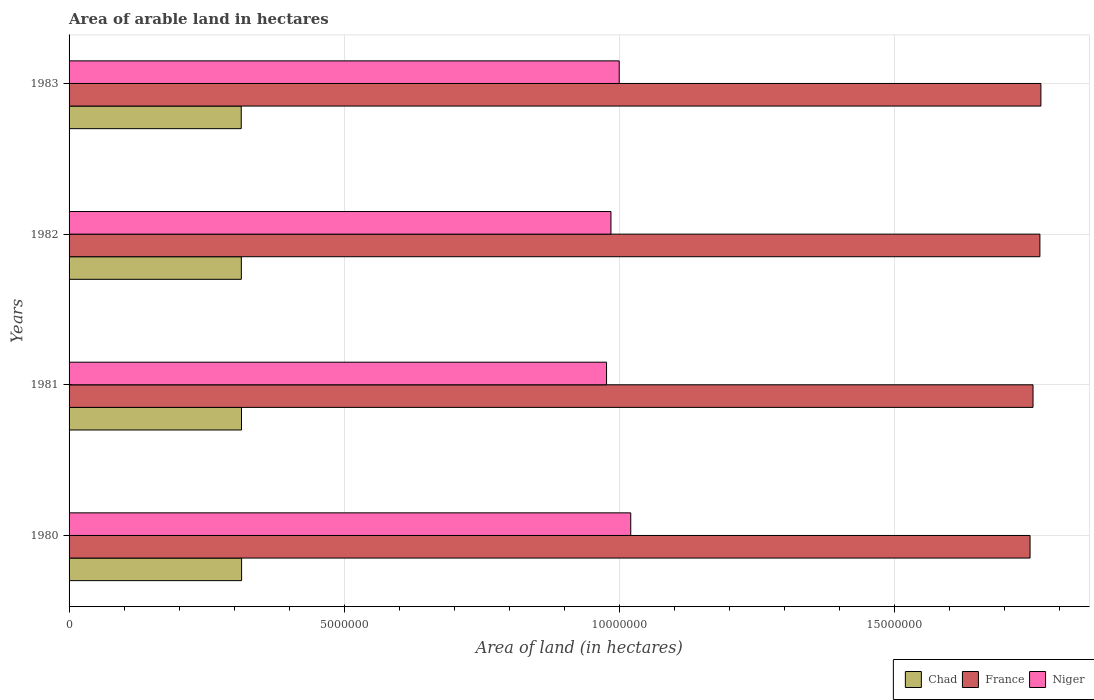How many different coloured bars are there?
Keep it short and to the point. 3. How many bars are there on the 3rd tick from the top?
Offer a very short reply. 3. What is the label of the 2nd group of bars from the top?
Give a very brief answer. 1982. In how many cases, is the number of bars for a given year not equal to the number of legend labels?
Keep it short and to the point. 0. What is the total arable land in Niger in 1981?
Keep it short and to the point. 9.77e+06. Across all years, what is the maximum total arable land in France?
Your answer should be compact. 1.77e+07. Across all years, what is the minimum total arable land in Chad?
Your answer should be very brief. 3.13e+06. In which year was the total arable land in Niger maximum?
Your answer should be compact. 1980. What is the total total arable land in France in the graph?
Make the answer very short. 7.03e+07. What is the difference between the total arable land in Chad in 1980 and that in 1983?
Your response must be concise. 7000. What is the difference between the total arable land in Niger in 1980 and the total arable land in France in 1982?
Ensure brevity in your answer.  -7.44e+06. What is the average total arable land in Chad per year?
Give a very brief answer. 3.13e+06. In the year 1980, what is the difference between the total arable land in France and total arable land in Chad?
Provide a short and direct response. 1.43e+07. What is the ratio of the total arable land in France in 1980 to that in 1983?
Provide a short and direct response. 0.99. Is the total arable land in Chad in 1980 less than that in 1983?
Make the answer very short. No. What is the difference between the highest and the lowest total arable land in Niger?
Offer a terse response. 4.40e+05. In how many years, is the total arable land in Niger greater than the average total arable land in Niger taken over all years?
Your response must be concise. 2. Is the sum of the total arable land in France in 1981 and 1982 greater than the maximum total arable land in Niger across all years?
Your answer should be very brief. Yes. What does the 3rd bar from the top in 1982 represents?
Your response must be concise. Chad. Is it the case that in every year, the sum of the total arable land in Chad and total arable land in Niger is greater than the total arable land in France?
Ensure brevity in your answer.  No. How many bars are there?
Your answer should be very brief. 12. Are the values on the major ticks of X-axis written in scientific E-notation?
Provide a short and direct response. No. Where does the legend appear in the graph?
Give a very brief answer. Bottom right. How many legend labels are there?
Make the answer very short. 3. How are the legend labels stacked?
Your response must be concise. Horizontal. What is the title of the graph?
Keep it short and to the point. Area of arable land in hectares. Does "Lao PDR" appear as one of the legend labels in the graph?
Make the answer very short. No. What is the label or title of the X-axis?
Provide a short and direct response. Area of land (in hectares). What is the Area of land (in hectares) of Chad in 1980?
Provide a short and direct response. 3.14e+06. What is the Area of land (in hectares) of France in 1980?
Make the answer very short. 1.75e+07. What is the Area of land (in hectares) of Niger in 1980?
Offer a very short reply. 1.02e+07. What is the Area of land (in hectares) in Chad in 1981?
Your answer should be compact. 3.14e+06. What is the Area of land (in hectares) of France in 1981?
Ensure brevity in your answer.  1.75e+07. What is the Area of land (in hectares) of Niger in 1981?
Your response must be concise. 9.77e+06. What is the Area of land (in hectares) of Chad in 1982?
Offer a very short reply. 3.13e+06. What is the Area of land (in hectares) in France in 1982?
Make the answer very short. 1.77e+07. What is the Area of land (in hectares) in Niger in 1982?
Your answer should be compact. 9.85e+06. What is the Area of land (in hectares) in Chad in 1983?
Ensure brevity in your answer.  3.13e+06. What is the Area of land (in hectares) of France in 1983?
Keep it short and to the point. 1.77e+07. What is the Area of land (in hectares) in Niger in 1983?
Make the answer very short. 1.00e+07. Across all years, what is the maximum Area of land (in hectares) in Chad?
Your answer should be very brief. 3.14e+06. Across all years, what is the maximum Area of land (in hectares) of France?
Your answer should be compact. 1.77e+07. Across all years, what is the maximum Area of land (in hectares) of Niger?
Ensure brevity in your answer.  1.02e+07. Across all years, what is the minimum Area of land (in hectares) of Chad?
Provide a succinct answer. 3.13e+06. Across all years, what is the minimum Area of land (in hectares) of France?
Keep it short and to the point. 1.75e+07. Across all years, what is the minimum Area of land (in hectares) in Niger?
Give a very brief answer. 9.77e+06. What is the total Area of land (in hectares) in Chad in the graph?
Ensure brevity in your answer.  1.25e+07. What is the total Area of land (in hectares) in France in the graph?
Provide a succinct answer. 7.03e+07. What is the total Area of land (in hectares) in Niger in the graph?
Your response must be concise. 3.98e+07. What is the difference between the Area of land (in hectares) in Chad in 1980 and that in 1981?
Provide a short and direct response. 2000. What is the difference between the Area of land (in hectares) in France in 1980 and that in 1981?
Provide a short and direct response. -5.40e+04. What is the difference between the Area of land (in hectares) in France in 1980 and that in 1982?
Make the answer very short. -1.79e+05. What is the difference between the Area of land (in hectares) of Chad in 1980 and that in 1983?
Give a very brief answer. 7000. What is the difference between the Area of land (in hectares) of France in 1980 and that in 1983?
Ensure brevity in your answer.  -1.97e+05. What is the difference between the Area of land (in hectares) of Niger in 1980 and that in 1983?
Provide a short and direct response. 2.10e+05. What is the difference between the Area of land (in hectares) of Chad in 1981 and that in 1982?
Offer a very short reply. 3000. What is the difference between the Area of land (in hectares) of France in 1981 and that in 1982?
Give a very brief answer. -1.25e+05. What is the difference between the Area of land (in hectares) in Chad in 1981 and that in 1983?
Give a very brief answer. 5000. What is the difference between the Area of land (in hectares) of France in 1981 and that in 1983?
Offer a terse response. -1.43e+05. What is the difference between the Area of land (in hectares) of Chad in 1982 and that in 1983?
Offer a very short reply. 2000. What is the difference between the Area of land (in hectares) of France in 1982 and that in 1983?
Provide a succinct answer. -1.80e+04. What is the difference between the Area of land (in hectares) in Chad in 1980 and the Area of land (in hectares) in France in 1981?
Ensure brevity in your answer.  -1.44e+07. What is the difference between the Area of land (in hectares) of Chad in 1980 and the Area of land (in hectares) of Niger in 1981?
Keep it short and to the point. -6.64e+06. What is the difference between the Area of land (in hectares) of France in 1980 and the Area of land (in hectares) of Niger in 1981?
Your answer should be compact. 7.70e+06. What is the difference between the Area of land (in hectares) in Chad in 1980 and the Area of land (in hectares) in France in 1982?
Provide a succinct answer. -1.45e+07. What is the difference between the Area of land (in hectares) of Chad in 1980 and the Area of land (in hectares) of Niger in 1982?
Your response must be concise. -6.72e+06. What is the difference between the Area of land (in hectares) in France in 1980 and the Area of land (in hectares) in Niger in 1982?
Your answer should be compact. 7.62e+06. What is the difference between the Area of land (in hectares) of Chad in 1980 and the Area of land (in hectares) of France in 1983?
Your answer should be compact. -1.45e+07. What is the difference between the Area of land (in hectares) of Chad in 1980 and the Area of land (in hectares) of Niger in 1983?
Provide a succinct answer. -6.86e+06. What is the difference between the Area of land (in hectares) in France in 1980 and the Area of land (in hectares) in Niger in 1983?
Make the answer very short. 7.47e+06. What is the difference between the Area of land (in hectares) in Chad in 1981 and the Area of land (in hectares) in France in 1982?
Give a very brief answer. -1.45e+07. What is the difference between the Area of land (in hectares) of Chad in 1981 and the Area of land (in hectares) of Niger in 1982?
Give a very brief answer. -6.72e+06. What is the difference between the Area of land (in hectares) in France in 1981 and the Area of land (in hectares) in Niger in 1982?
Provide a succinct answer. 7.67e+06. What is the difference between the Area of land (in hectares) of Chad in 1981 and the Area of land (in hectares) of France in 1983?
Offer a terse response. -1.45e+07. What is the difference between the Area of land (in hectares) in Chad in 1981 and the Area of land (in hectares) in Niger in 1983?
Your answer should be very brief. -6.87e+06. What is the difference between the Area of land (in hectares) in France in 1981 and the Area of land (in hectares) in Niger in 1983?
Your response must be concise. 7.52e+06. What is the difference between the Area of land (in hectares) in Chad in 1982 and the Area of land (in hectares) in France in 1983?
Keep it short and to the point. -1.45e+07. What is the difference between the Area of land (in hectares) in Chad in 1982 and the Area of land (in hectares) in Niger in 1983?
Your response must be concise. -6.87e+06. What is the difference between the Area of land (in hectares) of France in 1982 and the Area of land (in hectares) of Niger in 1983?
Make the answer very short. 7.65e+06. What is the average Area of land (in hectares) in Chad per year?
Your answer should be very brief. 3.13e+06. What is the average Area of land (in hectares) of France per year?
Give a very brief answer. 1.76e+07. What is the average Area of land (in hectares) in Niger per year?
Your response must be concise. 9.96e+06. In the year 1980, what is the difference between the Area of land (in hectares) of Chad and Area of land (in hectares) of France?
Offer a very short reply. -1.43e+07. In the year 1980, what is the difference between the Area of land (in hectares) in Chad and Area of land (in hectares) in Niger?
Your answer should be very brief. -7.08e+06. In the year 1980, what is the difference between the Area of land (in hectares) in France and Area of land (in hectares) in Niger?
Make the answer very short. 7.26e+06. In the year 1981, what is the difference between the Area of land (in hectares) of Chad and Area of land (in hectares) of France?
Provide a succinct answer. -1.44e+07. In the year 1981, what is the difference between the Area of land (in hectares) of Chad and Area of land (in hectares) of Niger?
Offer a very short reply. -6.64e+06. In the year 1981, what is the difference between the Area of land (in hectares) in France and Area of land (in hectares) in Niger?
Make the answer very short. 7.75e+06. In the year 1982, what is the difference between the Area of land (in hectares) of Chad and Area of land (in hectares) of France?
Keep it short and to the point. -1.45e+07. In the year 1982, what is the difference between the Area of land (in hectares) in Chad and Area of land (in hectares) in Niger?
Your answer should be compact. -6.72e+06. In the year 1982, what is the difference between the Area of land (in hectares) in France and Area of land (in hectares) in Niger?
Provide a succinct answer. 7.80e+06. In the year 1983, what is the difference between the Area of land (in hectares) in Chad and Area of land (in hectares) in France?
Keep it short and to the point. -1.45e+07. In the year 1983, what is the difference between the Area of land (in hectares) of Chad and Area of land (in hectares) of Niger?
Ensure brevity in your answer.  -6.87e+06. In the year 1983, what is the difference between the Area of land (in hectares) in France and Area of land (in hectares) in Niger?
Provide a succinct answer. 7.67e+06. What is the ratio of the Area of land (in hectares) in France in 1980 to that in 1981?
Offer a terse response. 1. What is the ratio of the Area of land (in hectares) in Niger in 1980 to that in 1981?
Ensure brevity in your answer.  1.04. What is the ratio of the Area of land (in hectares) of Niger in 1980 to that in 1982?
Provide a succinct answer. 1.04. What is the ratio of the Area of land (in hectares) in Chad in 1980 to that in 1983?
Ensure brevity in your answer.  1. What is the ratio of the Area of land (in hectares) of France in 1980 to that in 1983?
Keep it short and to the point. 0.99. What is the ratio of the Area of land (in hectares) of Chad in 1981 to that in 1982?
Make the answer very short. 1. What is the ratio of the Area of land (in hectares) in France in 1981 to that in 1982?
Offer a very short reply. 0.99. What is the ratio of the Area of land (in hectares) in Niger in 1981 to that in 1982?
Make the answer very short. 0.99. What is the ratio of the Area of land (in hectares) in Chad in 1981 to that in 1983?
Ensure brevity in your answer.  1. What is the ratio of the Area of land (in hectares) of Niger in 1982 to that in 1983?
Offer a very short reply. 0.98. What is the difference between the highest and the second highest Area of land (in hectares) in France?
Provide a short and direct response. 1.80e+04. What is the difference between the highest and the second highest Area of land (in hectares) in Niger?
Provide a succinct answer. 2.10e+05. What is the difference between the highest and the lowest Area of land (in hectares) in Chad?
Your answer should be very brief. 7000. What is the difference between the highest and the lowest Area of land (in hectares) in France?
Your answer should be very brief. 1.97e+05. 